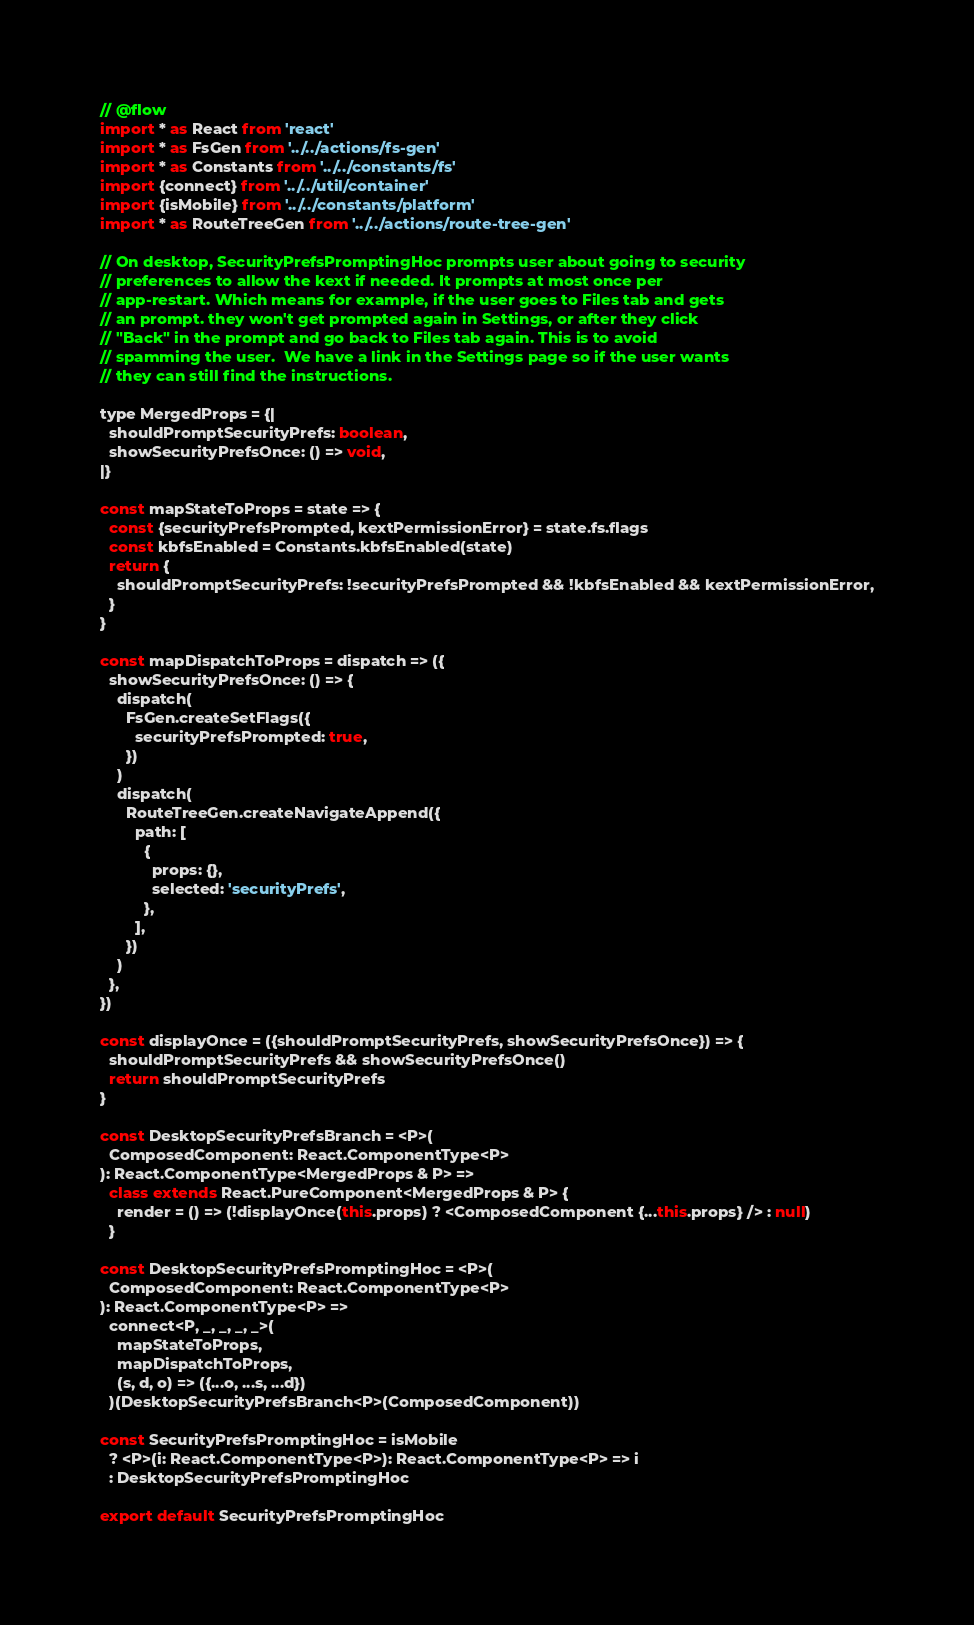Convert code to text. <code><loc_0><loc_0><loc_500><loc_500><_JavaScript_>// @flow
import * as React from 'react'
import * as FsGen from '../../actions/fs-gen'
import * as Constants from '../../constants/fs'
import {connect} from '../../util/container'
import {isMobile} from '../../constants/platform'
import * as RouteTreeGen from '../../actions/route-tree-gen'

// On desktop, SecurityPrefsPromptingHoc prompts user about going to security
// preferences to allow the kext if needed. It prompts at most once per
// app-restart. Which means for example, if the user goes to Files tab and gets
// an prompt. they won't get prompted again in Settings, or after they click
// "Back" in the prompt and go back to Files tab again. This is to avoid
// spamming the user.  We have a link in the Settings page so if the user wants
// they can still find the instructions.

type MergedProps = {|
  shouldPromptSecurityPrefs: boolean,
  showSecurityPrefsOnce: () => void,
|}

const mapStateToProps = state => {
  const {securityPrefsPrompted, kextPermissionError} = state.fs.flags
  const kbfsEnabled = Constants.kbfsEnabled(state)
  return {
    shouldPromptSecurityPrefs: !securityPrefsPrompted && !kbfsEnabled && kextPermissionError,
  }
}

const mapDispatchToProps = dispatch => ({
  showSecurityPrefsOnce: () => {
    dispatch(
      FsGen.createSetFlags({
        securityPrefsPrompted: true,
      })
    )
    dispatch(
      RouteTreeGen.createNavigateAppend({
        path: [
          {
            props: {},
            selected: 'securityPrefs',
          },
        ],
      })
    )
  },
})

const displayOnce = ({shouldPromptSecurityPrefs, showSecurityPrefsOnce}) => {
  shouldPromptSecurityPrefs && showSecurityPrefsOnce()
  return shouldPromptSecurityPrefs
}

const DesktopSecurityPrefsBranch = <P>(
  ComposedComponent: React.ComponentType<P>
): React.ComponentType<MergedProps & P> =>
  class extends React.PureComponent<MergedProps & P> {
    render = () => (!displayOnce(this.props) ? <ComposedComponent {...this.props} /> : null)
  }

const DesktopSecurityPrefsPromptingHoc = <P>(
  ComposedComponent: React.ComponentType<P>
): React.ComponentType<P> =>
  connect<P, _, _, _, _>(
    mapStateToProps,
    mapDispatchToProps,
    (s, d, o) => ({...o, ...s, ...d})
  )(DesktopSecurityPrefsBranch<P>(ComposedComponent))

const SecurityPrefsPromptingHoc = isMobile
  ? <P>(i: React.ComponentType<P>): React.ComponentType<P> => i
  : DesktopSecurityPrefsPromptingHoc

export default SecurityPrefsPromptingHoc
</code> 